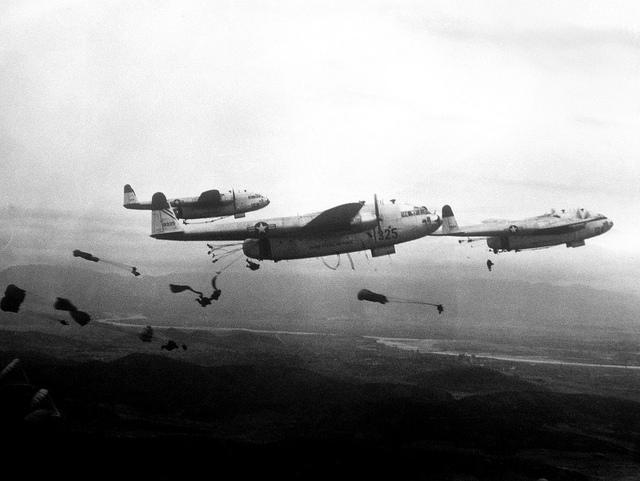How many planes are flying?
Give a very brief answer. 3. How many airplanes can you see?
Give a very brief answer. 3. How many blue trucks are there?
Give a very brief answer. 0. 